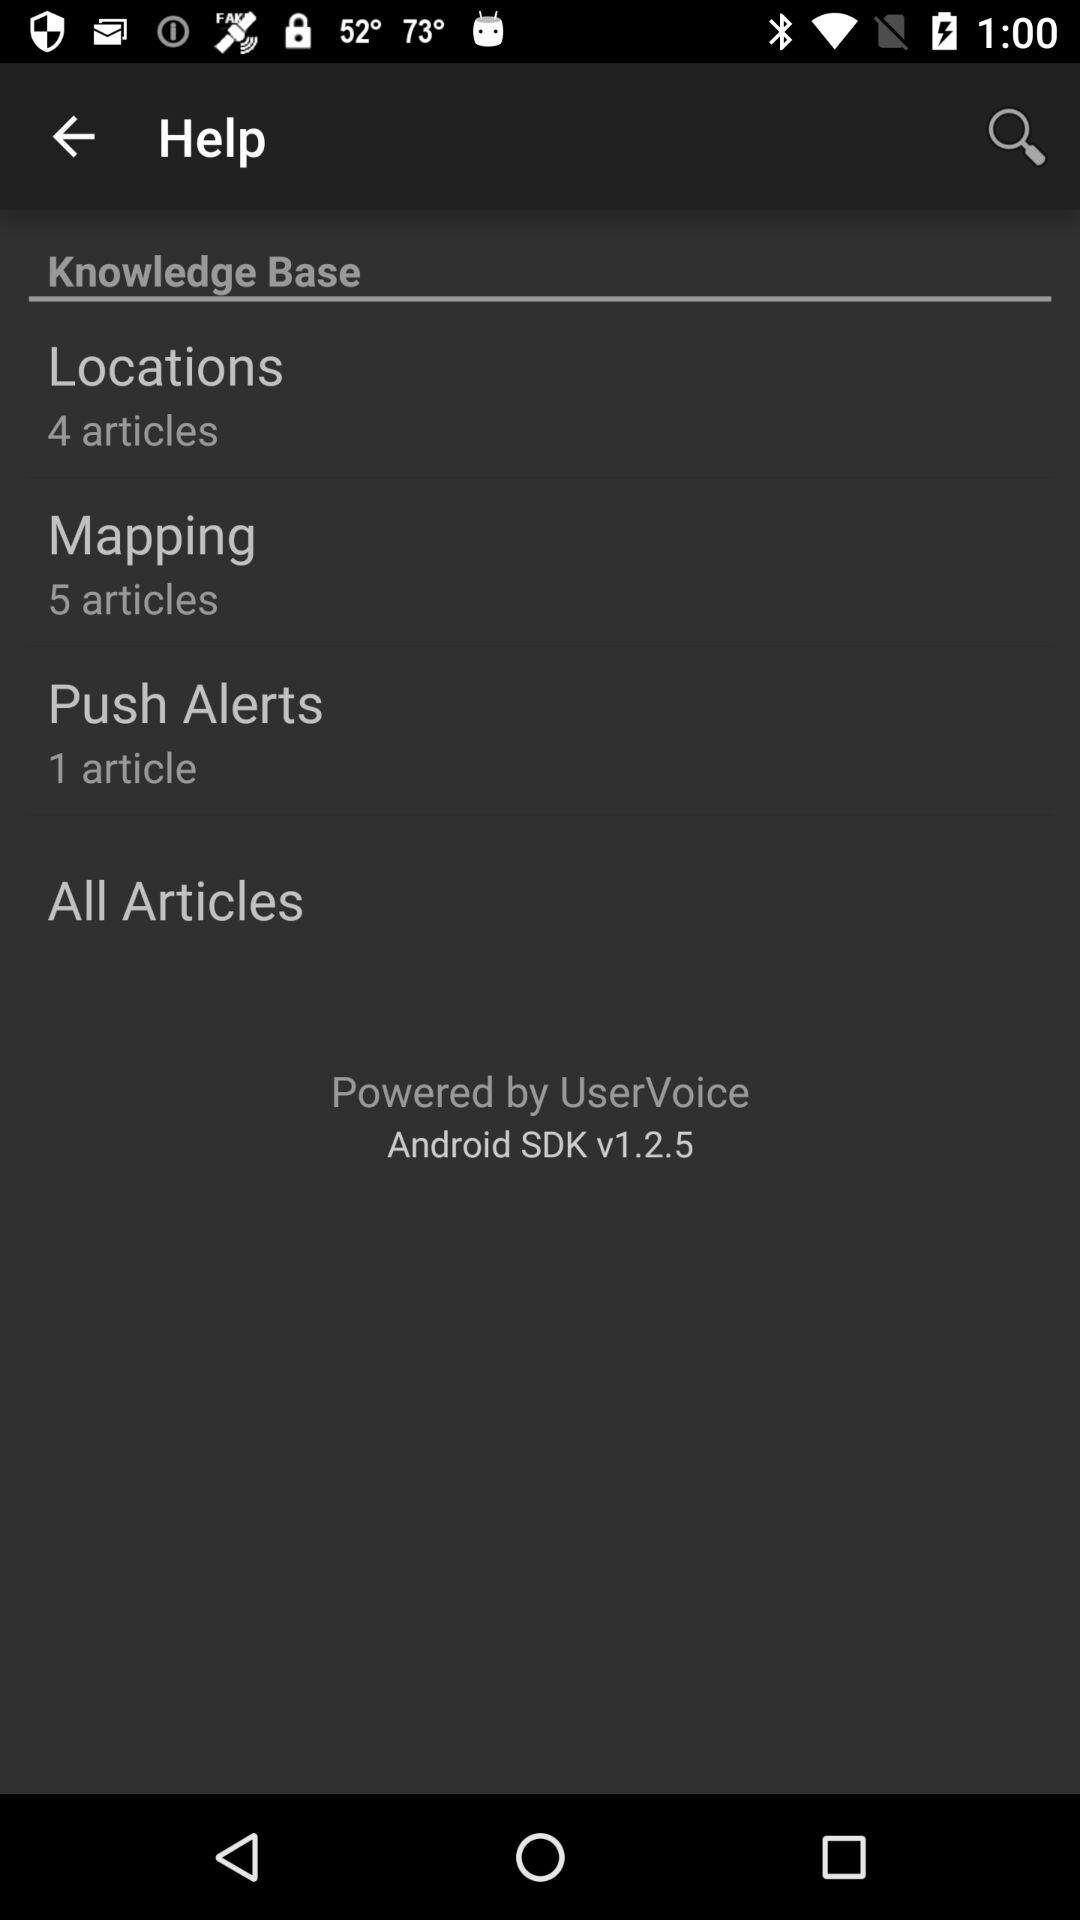What is the version of the app? The version is v1.2.5. 